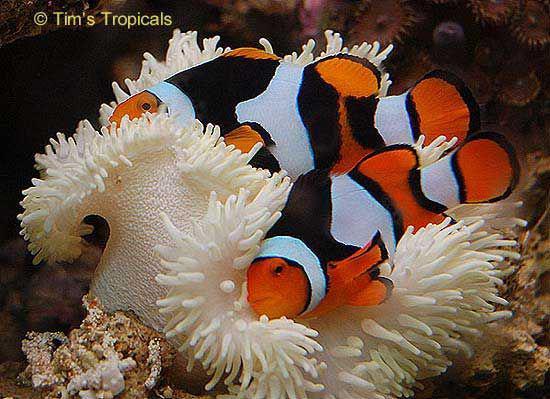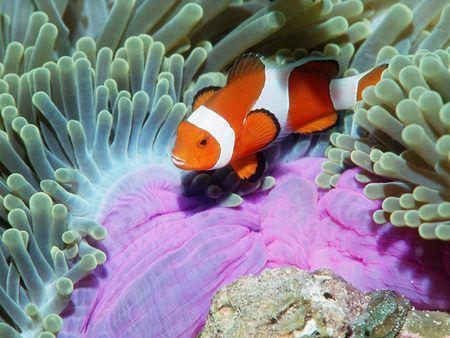The first image is the image on the left, the second image is the image on the right. For the images shown, is this caption "Each image includes a striped fish swimming near the tendrils of an anemone." true? Answer yes or no. Yes. The first image is the image on the left, the second image is the image on the right. Analyze the images presented: Is the assertion "A yellow, black and white striped fish is swimming around sea plants in the image on the left." valid? Answer yes or no. No. 